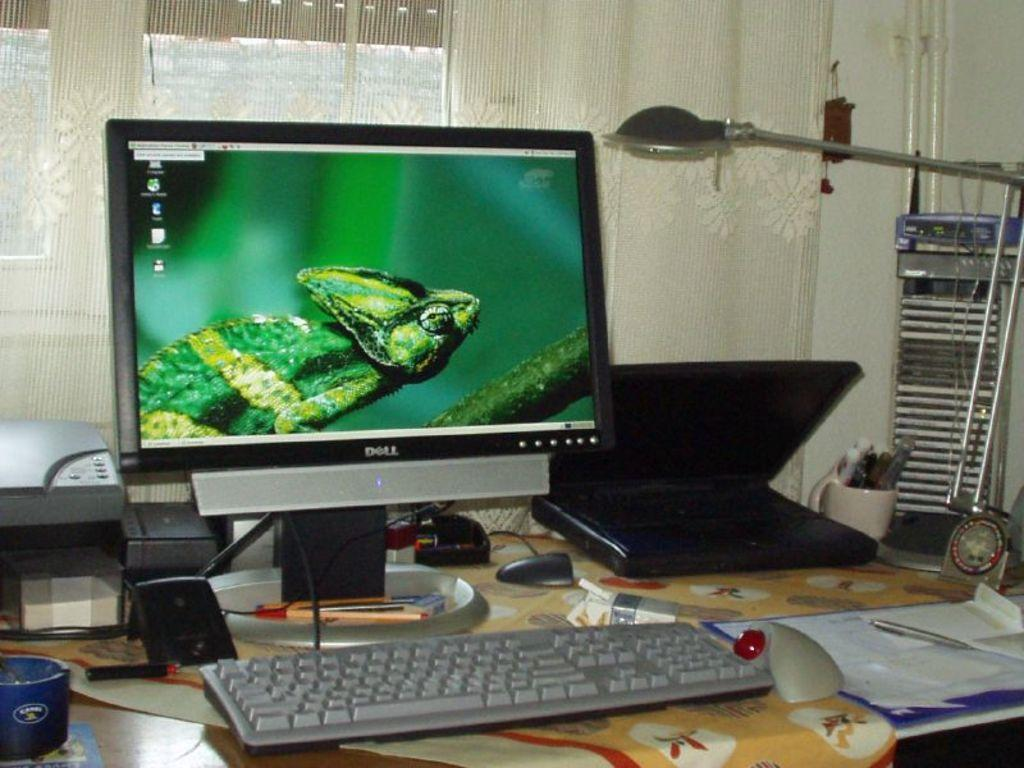<image>
Relay a brief, clear account of the picture shown. a desktop computer with a iguana on the display screen 